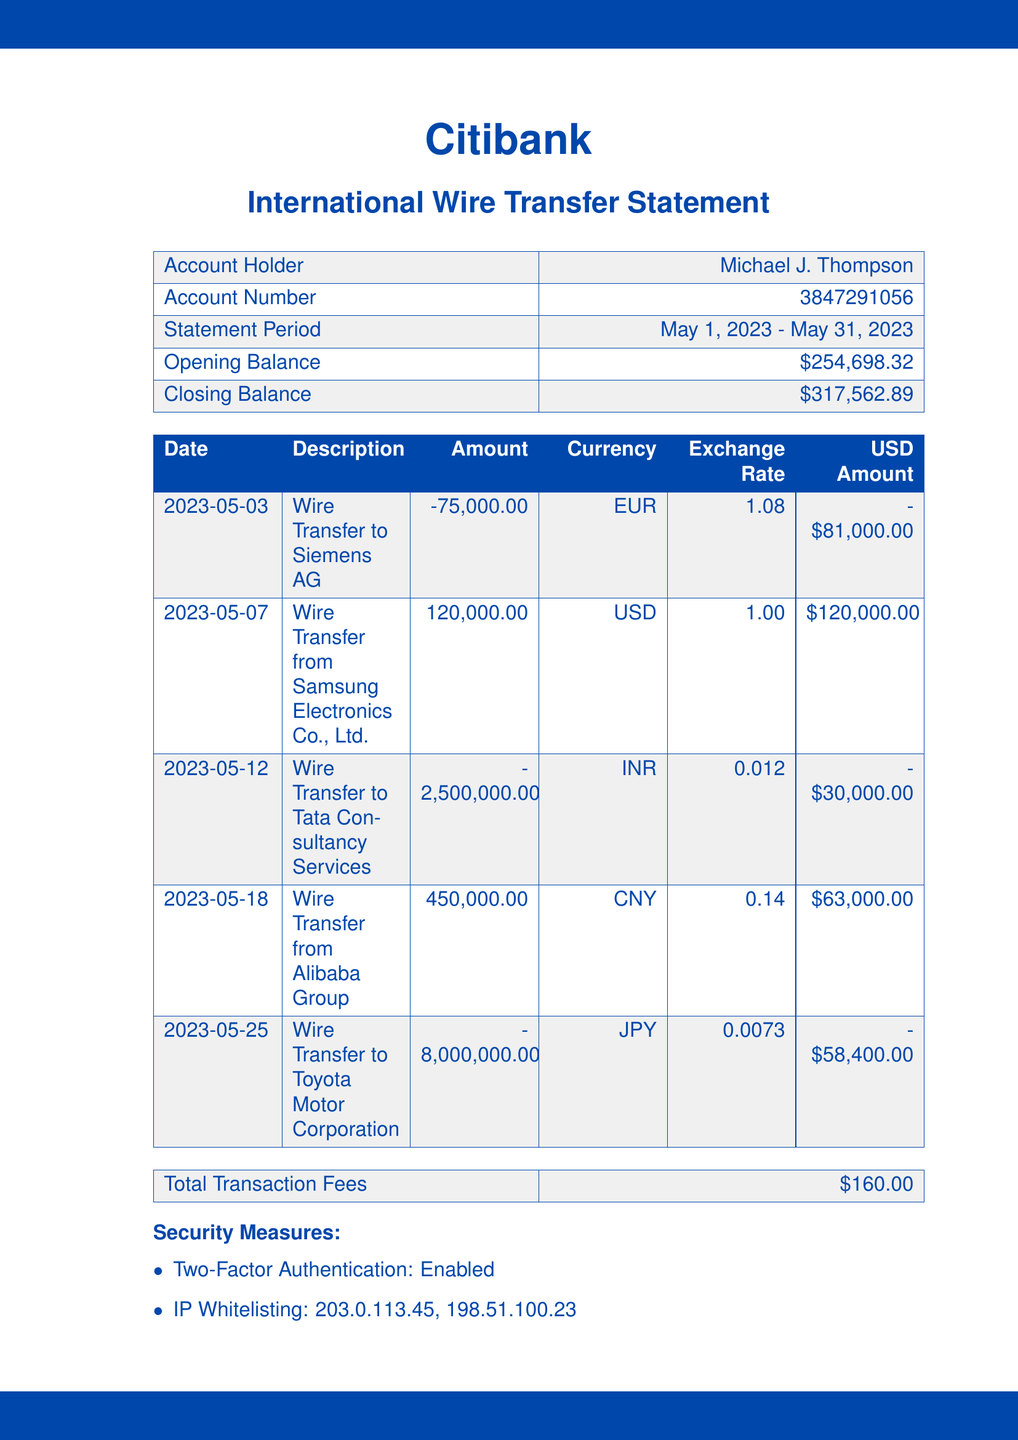What is the account holder's name? The account holder's name is listed at the top of the document.
Answer: Michael J. Thompson What is the closing balance? The closing balance is specified as the final amount at the end of the statement period.
Answer: $317,562.89 How much was the wire transfer to Siemens AG? This information shows how much was transferred out to Siemens AG on a specific date.
Answer: -75,000.00 What is the total transaction fees charged? The total transaction fees are listed near the bottom of the document.
Answer: $160.00 What was the amount received from Alibaba Group? This is detailed in the transactions section for the specific date related to Alibaba Group.
Answer: 450,000.00 What currency was used for the wire transfer to Tata Consultancy Services? This is specified in the description of the transaction for Tata Consultancy Services.
Answer: INR On what date was the last password change? The date of the last password change is mentioned under security measures.
Answer: 2023-04-15 What type of security measure is enabled? This refers to a specific feature mentioned under security measures in the document.
Answer: Two-Factor Authentication What is the exchange rate for EUR? The average exchange rate for EUR is provided in the summary section of the document.
Answer: 1.08 